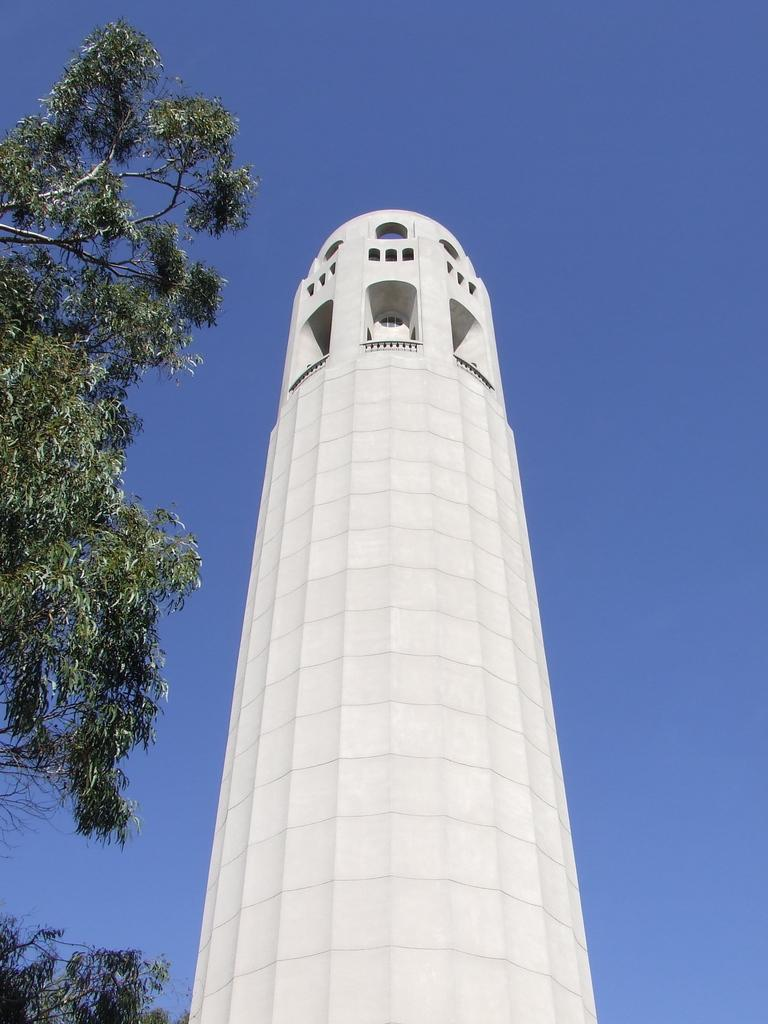What is the main subject in the foreground of the image? There is a tower in the foreground of the image. What can be seen on the left side of the image? There are trees on the left side of the image. What is visible at the top of the image? The sky is visible at the top of the image. What type of company is located in the square in the image? There is no square present in the image, and therefore no company can be associated with it. 